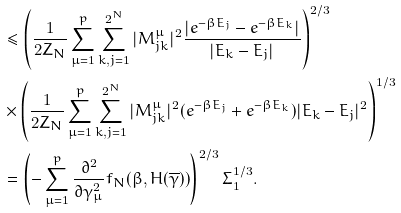Convert formula to latex. <formula><loc_0><loc_0><loc_500><loc_500>& \leq \left ( \frac { 1 } { 2 Z _ { N } } \sum _ { \mu = 1 } ^ { p } \sum _ { k , j = 1 } ^ { 2 ^ { N } } | M ^ { \mu } _ { j k } | ^ { 2 } \frac { | e ^ { - \beta E _ { j } } - e ^ { - \beta E _ { k } } | } { | E _ { k } - E _ { j } | } \right ) ^ { 2 / 3 } \\ & \times \left ( \frac { 1 } { 2 Z _ { N } } \sum _ { \mu = 1 } ^ { p } \sum _ { k , j = 1 } ^ { 2 ^ { N } } | M ^ { \mu } _ { j k } | ^ { 2 } ( e ^ { - \beta E _ { j } } + e ^ { - \beta E _ { k } } ) | E _ { k } - E _ { j } | ^ { 2 } \right ) ^ { 1 / 3 } \\ & = \left ( - \sum _ { \mu = 1 } ^ { p } \frac { \partial ^ { 2 } } { \partial \gamma _ { \mu } ^ { 2 } } f _ { N } ( \beta , H ( \overline { \gamma } ) ) \right ) ^ { 2 / 3 } \Sigma _ { 1 } ^ { 1 / 3 } .</formula> 